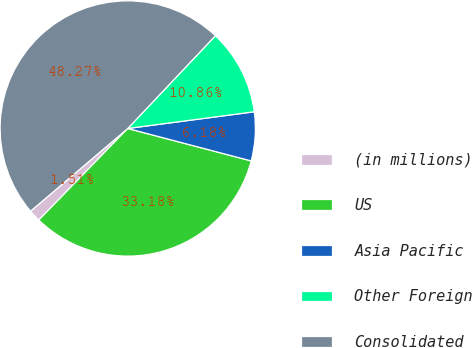<chart> <loc_0><loc_0><loc_500><loc_500><pie_chart><fcel>(in millions)<fcel>US<fcel>Asia Pacific<fcel>Other Foreign<fcel>Consolidated<nl><fcel>1.51%<fcel>33.18%<fcel>6.18%<fcel>10.86%<fcel>48.27%<nl></chart> 